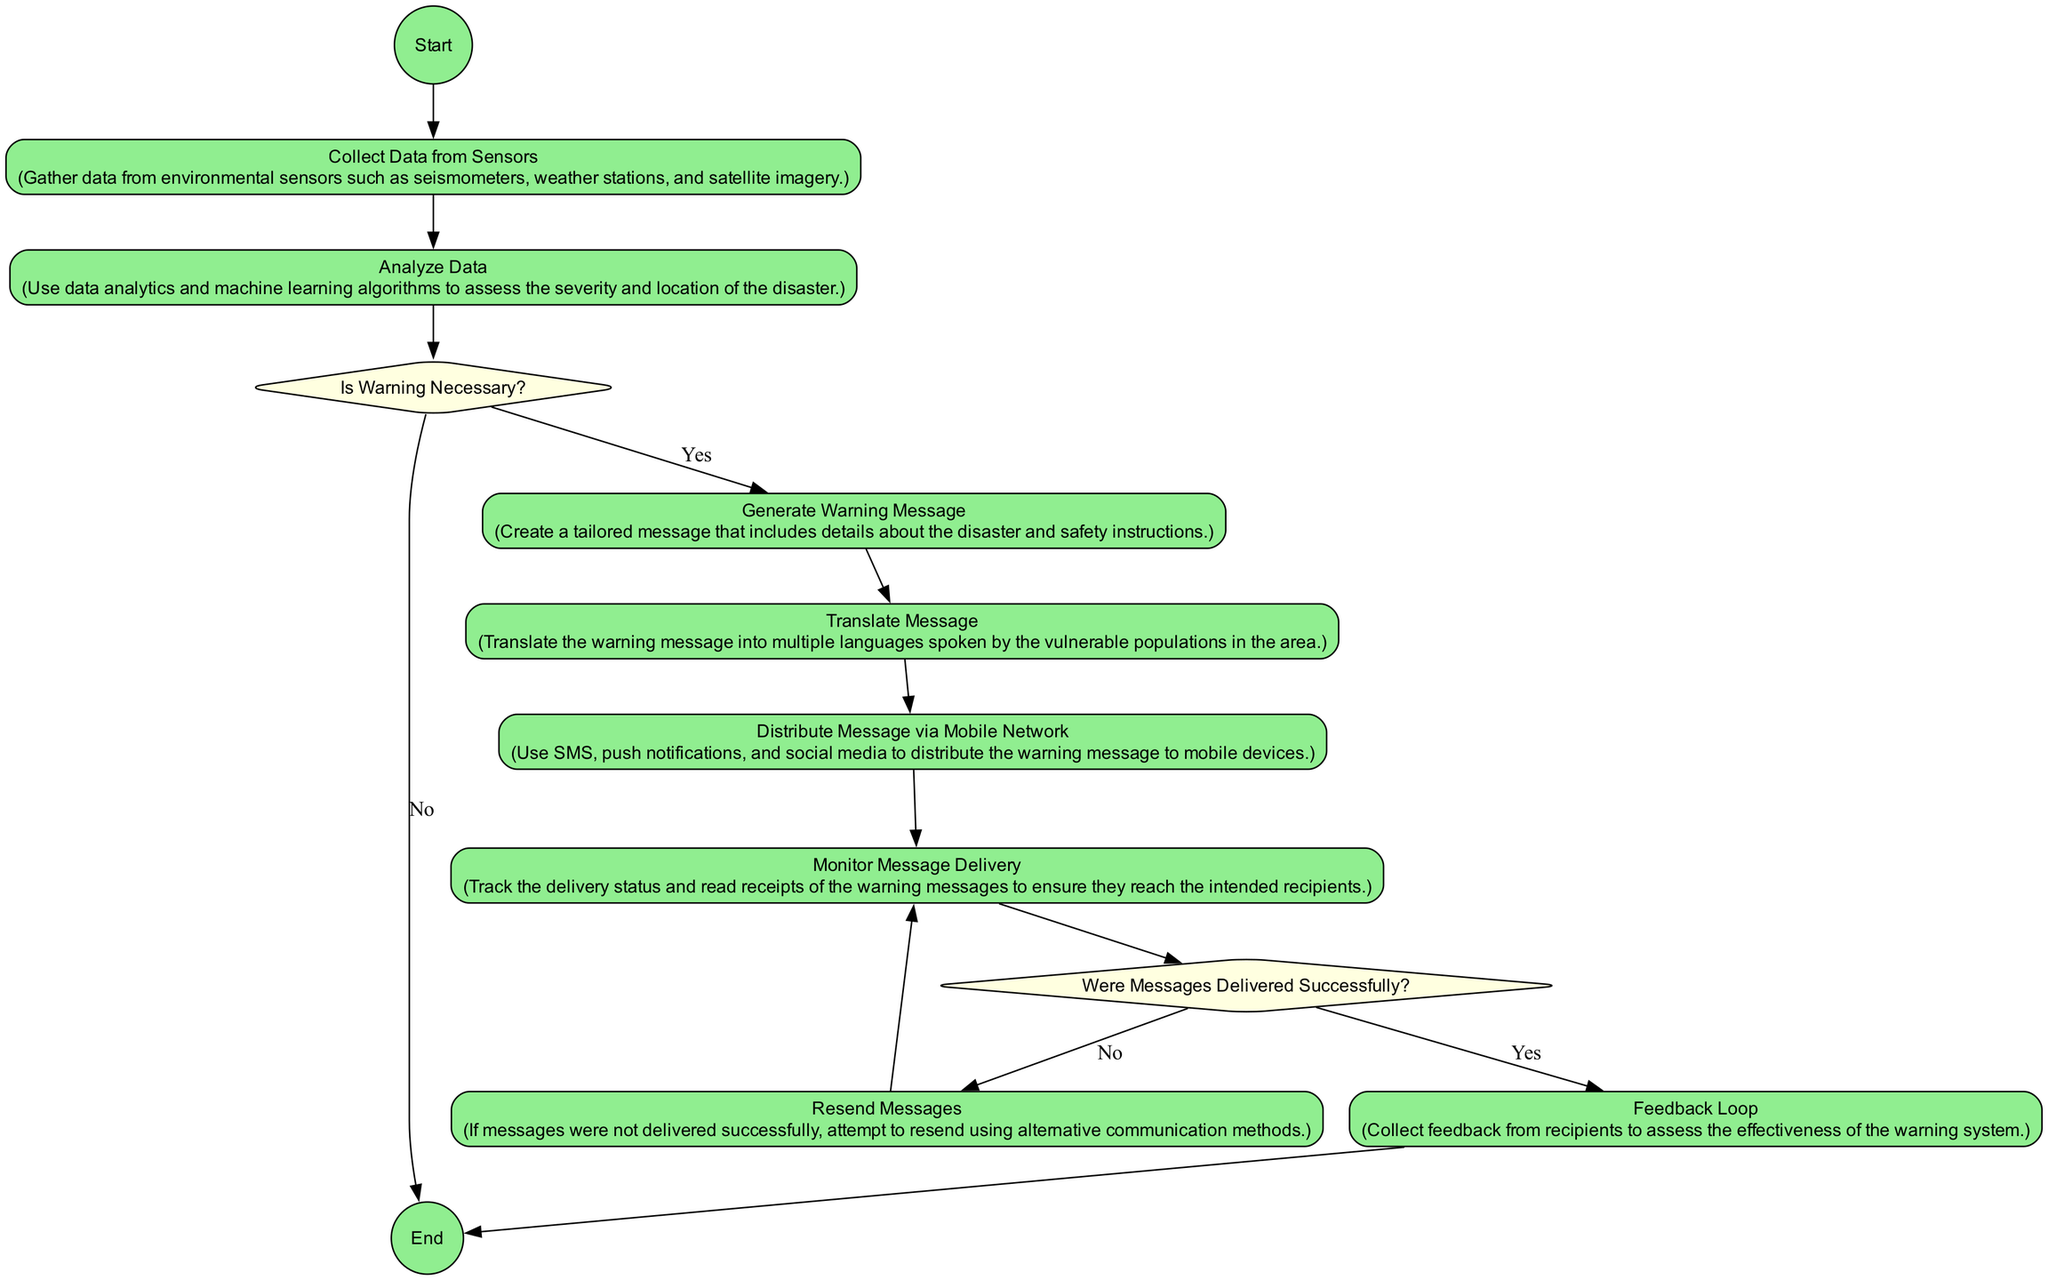What is the starting event in the diagram? The starting event in the diagram is labeled as "Disaster Detected." This is clearly indicated as the first node in the flow.
Answer: Disaster Detected What type of node follows "Analyze Data"? The node that follows "Analyze Data" is a decision node named "Is Warning Necessary?" which determines the next steps in the process.
Answer: Decision How many activity nodes are present in the diagram? There are six activity nodes in the diagram: "Collect Data from Sensors," "Analyze Data," "Generate Warning Message," "Translate Message," "Distribute Message via Mobile Network," and "Feedback Loop."
Answer: Six What happens if "Is Warning Necessary?" is answered with "No"? If "Is Warning Necessary?" is answered with "No," the flow goes directly to the end event labeled "Warning System Operation Complete."
Answer: End What is the next step after "Translate Message"? After "Translate Message," the next step in the flow is "Distribute Message via Mobile Network," which involves sending out the warning message.
Answer: Distribute Message via Mobile Network If messages are not delivered successfully, what action is taken? If messages are not delivered successfully, the action taken is to "Resend Messages" using alternative communication methods to ensure delivery.
Answer: Resend Messages What type of messages are being monitored? The messages being monitored are the warning messages sent to the vulnerable populations, ensuring they reach the intended recipients.
Answer: Warning messages What does the "Feedback Loop" activity assess? The "Feedback Loop" activity assesses the effectiveness of the warning system by collecting feedback from recipients who received the message.
Answer: Effectiveness 